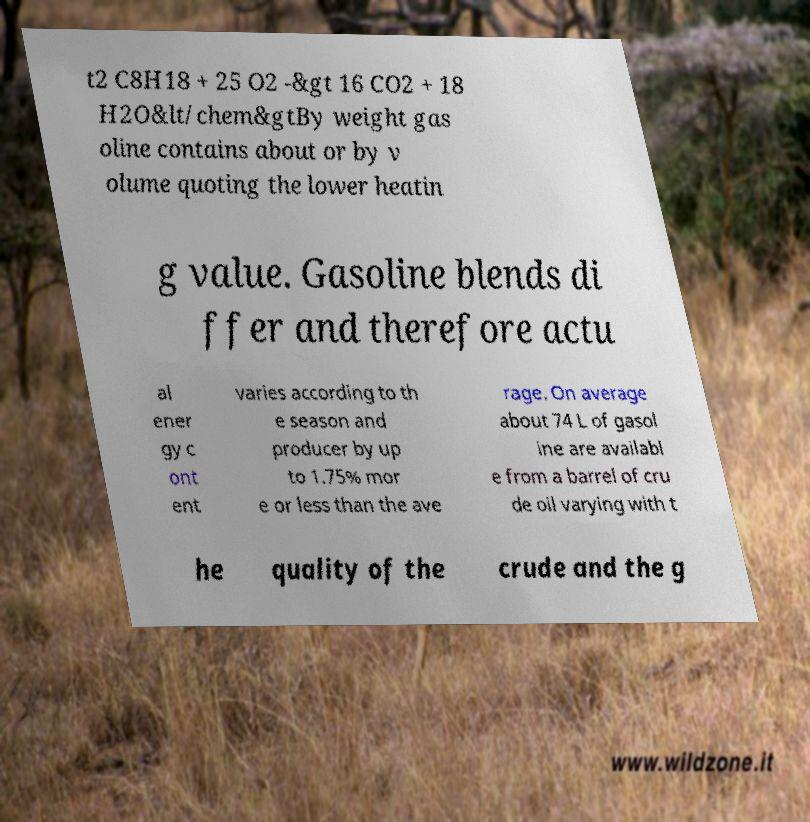Can you read and provide the text displayed in the image?This photo seems to have some interesting text. Can you extract and type it out for me? t2 C8H18 + 25 O2 -&gt 16 CO2 + 18 H2O&lt/chem&gtBy weight gas oline contains about or by v olume quoting the lower heatin g value. Gasoline blends di ffer and therefore actu al ener gy c ont ent varies according to th e season and producer by up to 1.75% mor e or less than the ave rage. On average about 74 L of gasol ine are availabl e from a barrel of cru de oil varying with t he quality of the crude and the g 